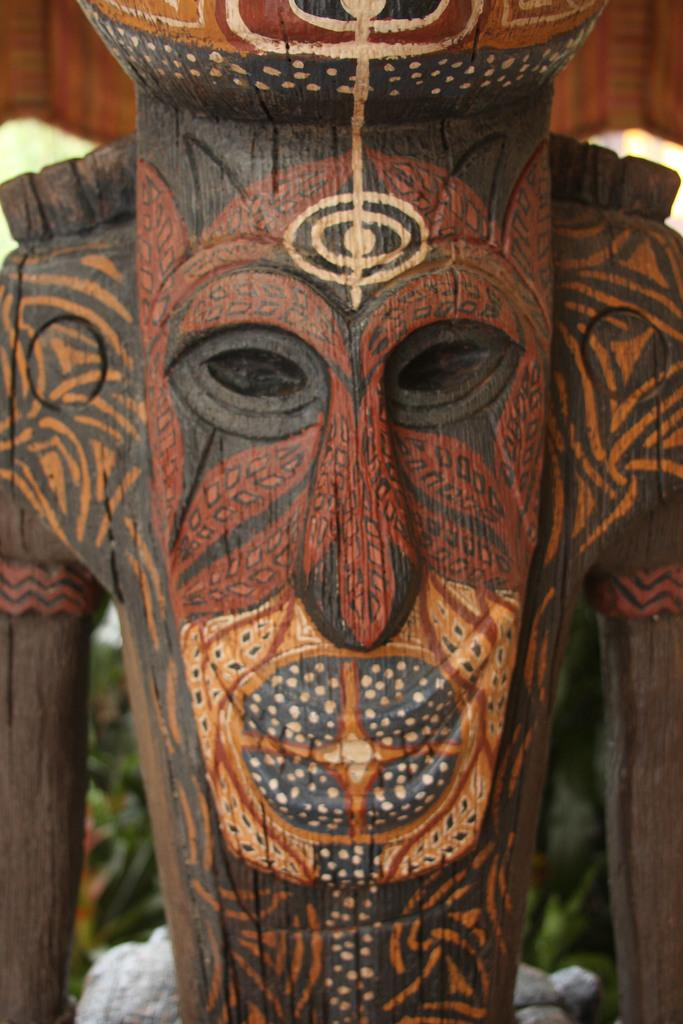What type of object is the main subject of the image? There is a wooden craft mask in the image. Can you describe the background of the image? The background of the image is blurred. What type of throat condition can be seen in the image? There is no throat condition present in the image; it features a wooden craft mask. Can you tell me how many poisonous substances are visible in the image? There are no poisonous substances visible in the image; it features a wooden craft mask. 